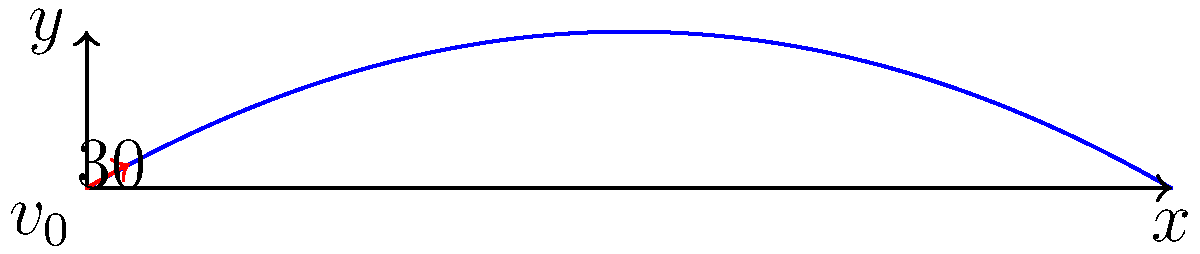As a graphic designer creating visuals for a physics wiki page, you need to illustrate the trajectory of a projectile. The projectile is launched with an initial velocity of 50 m/s at an angle of 30° above the horizontal. What is the maximum height reached by the projectile? Round your answer to the nearest tenth of a meter. To find the maximum height of the projectile, we'll follow these steps:

1) The maximum height is reached when the vertical component of velocity becomes zero. We can use the equation:

   $y_{max} = \frac{(v_0 \sin \theta)^2}{2g}$

   Where:
   $v_0$ is the initial velocity
   $\theta$ is the launch angle
   $g$ is the acceleration due to gravity (9.8 m/s²)

2) We're given:
   $v_0 = 50$ m/s
   $\theta = 30°$

3) First, let's calculate $\sin 30°$:
   $\sin 30° = 0.5$

4) Now, let's substitute the values into our equation:

   $y_{max} = \frac{(50 \cdot 0.5)^2}{2 \cdot 9.8}$

5) Simplify:
   $y_{max} = \frac{625}{19.6} \approx 31.89$ m

6) Rounding to the nearest tenth:
   $y_{max} \approx 31.9$ m

Therefore, the maximum height reached by the projectile is approximately 31.9 meters.
Answer: 31.9 m 